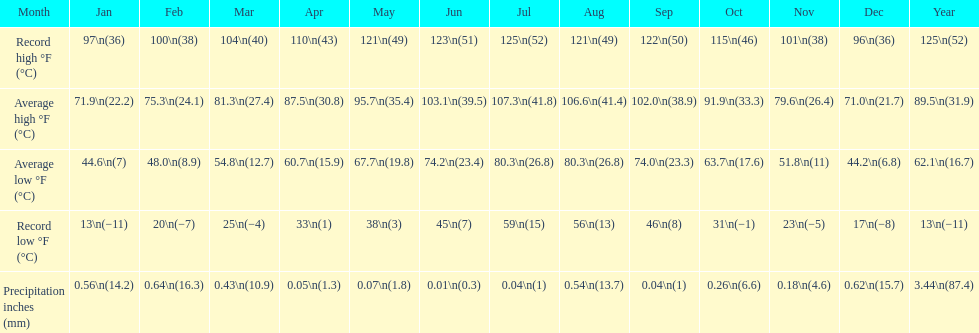In how many months did record low temperatures fall below freezing? 7. 